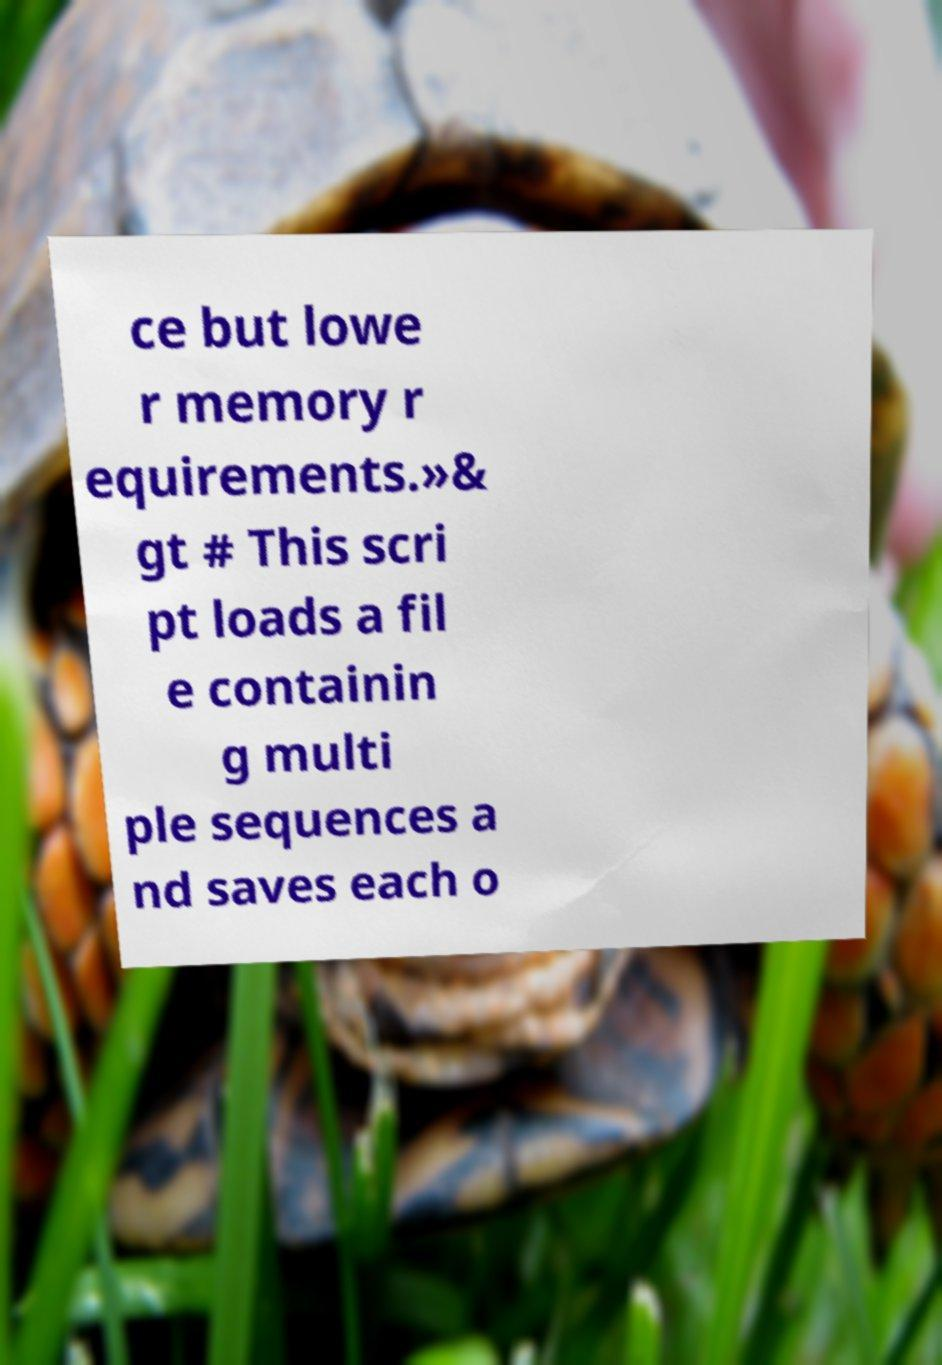Please identify and transcribe the text found in this image. ce but lowe r memory r equirements.»& gt # This scri pt loads a fil e containin g multi ple sequences a nd saves each o 